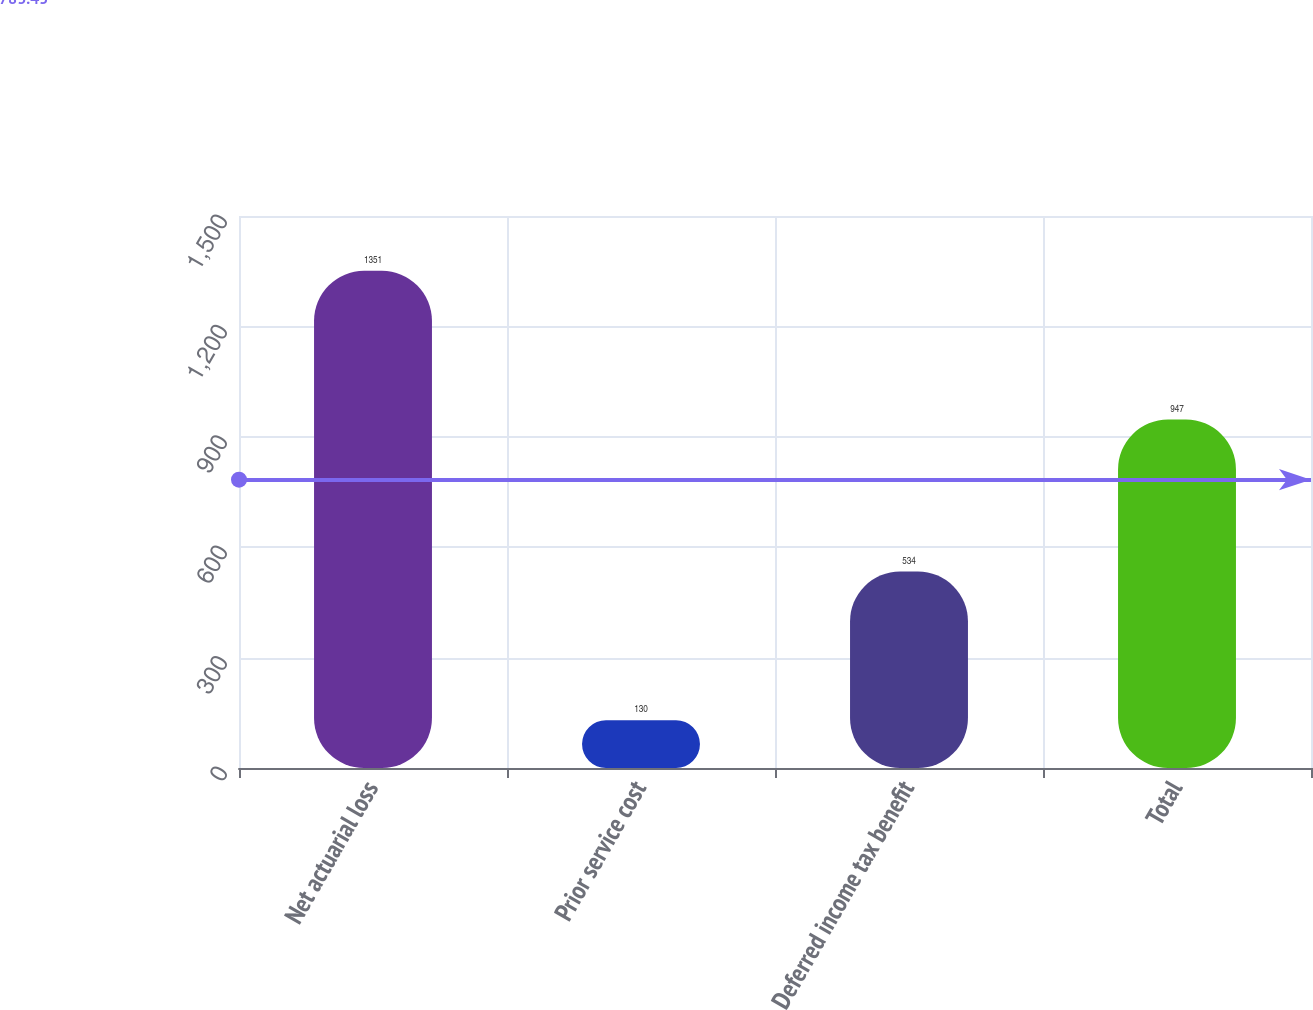<chart> <loc_0><loc_0><loc_500><loc_500><bar_chart><fcel>Net actuarial loss<fcel>Prior service cost<fcel>Deferred income tax benefit<fcel>Total<nl><fcel>1351<fcel>130<fcel>534<fcel>947<nl></chart> 